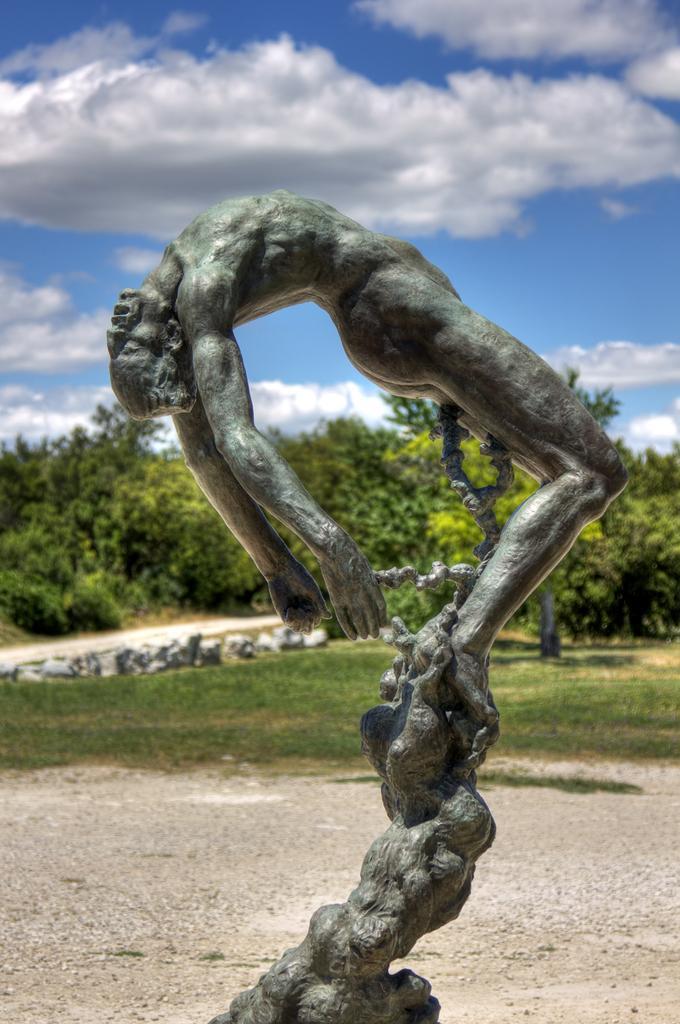Could you give a brief overview of what you see in this image? As we can see in the image in the front there is a statue and grass. In the background there are trees. On the top there is sky and clouds. 